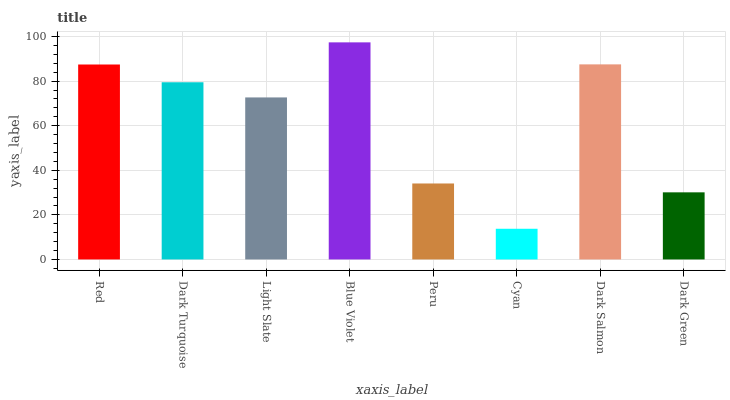Is Cyan the minimum?
Answer yes or no. Yes. Is Blue Violet the maximum?
Answer yes or no. Yes. Is Dark Turquoise the minimum?
Answer yes or no. No. Is Dark Turquoise the maximum?
Answer yes or no. No. Is Red greater than Dark Turquoise?
Answer yes or no. Yes. Is Dark Turquoise less than Red?
Answer yes or no. Yes. Is Dark Turquoise greater than Red?
Answer yes or no. No. Is Red less than Dark Turquoise?
Answer yes or no. No. Is Dark Turquoise the high median?
Answer yes or no. Yes. Is Light Slate the low median?
Answer yes or no. Yes. Is Blue Violet the high median?
Answer yes or no. No. Is Dark Turquoise the low median?
Answer yes or no. No. 